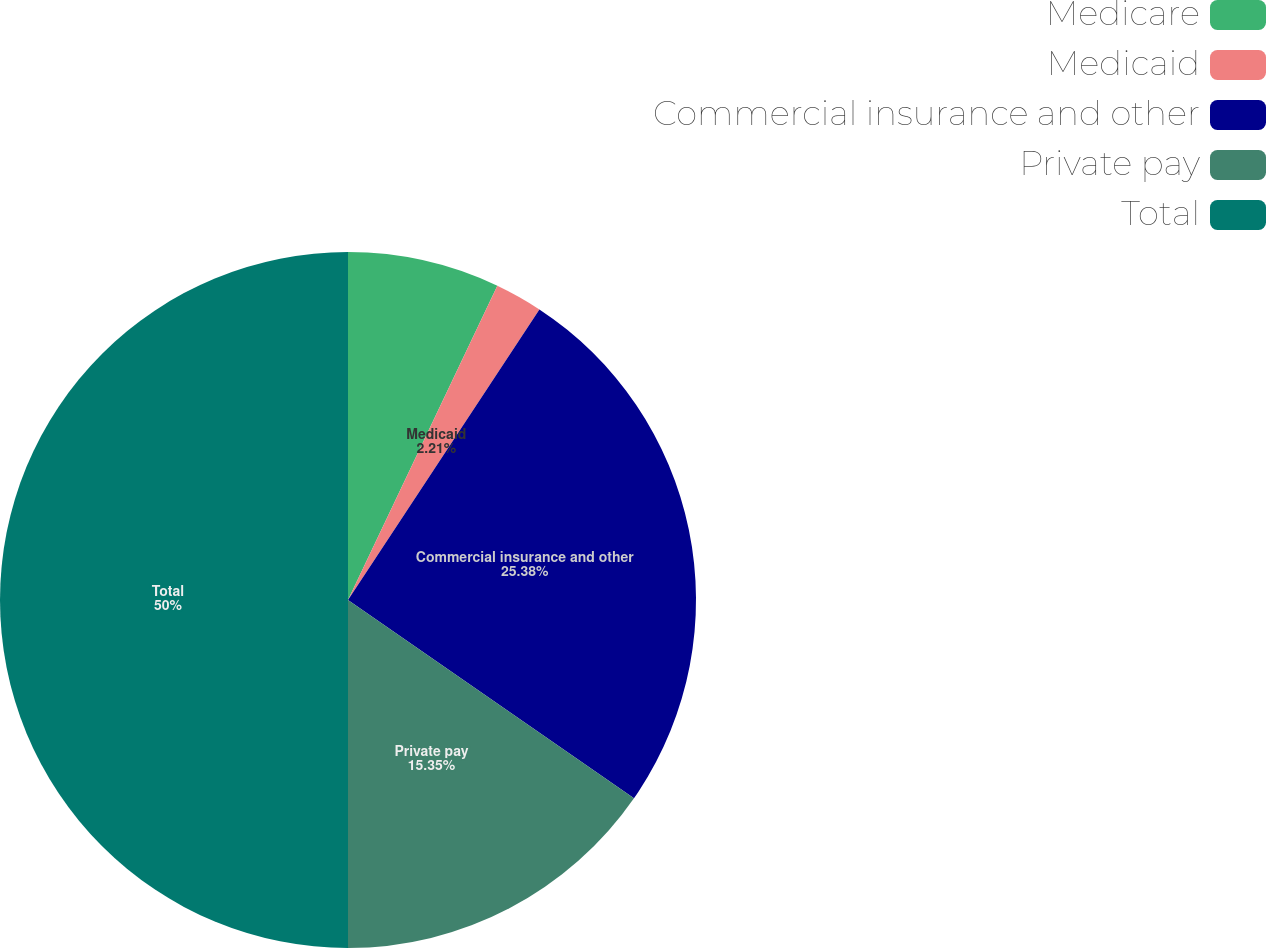Convert chart to OTSL. <chart><loc_0><loc_0><loc_500><loc_500><pie_chart><fcel>Medicare<fcel>Medicaid<fcel>Commercial insurance and other<fcel>Private pay<fcel>Total<nl><fcel>7.06%<fcel>2.21%<fcel>25.38%<fcel>15.35%<fcel>50.0%<nl></chart> 